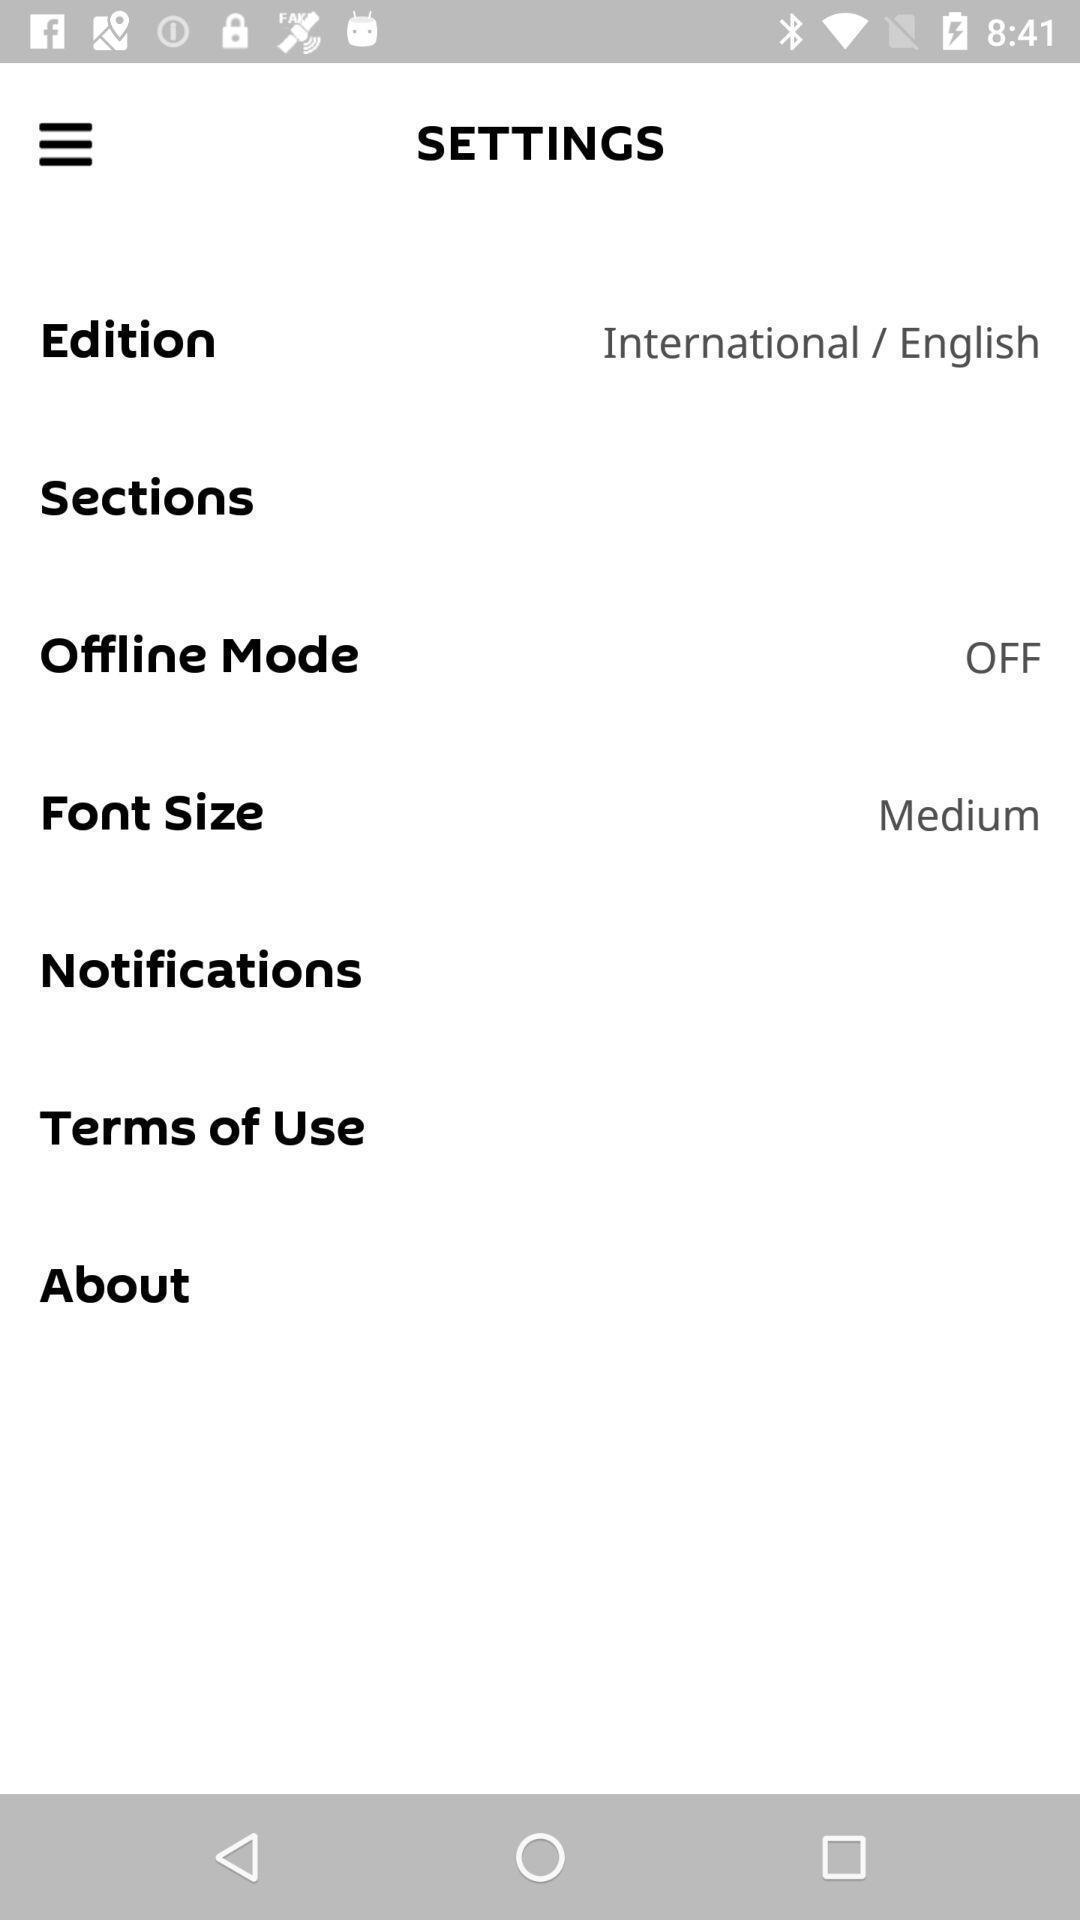Provide a textual representation of this image. Settings page of a news app. 